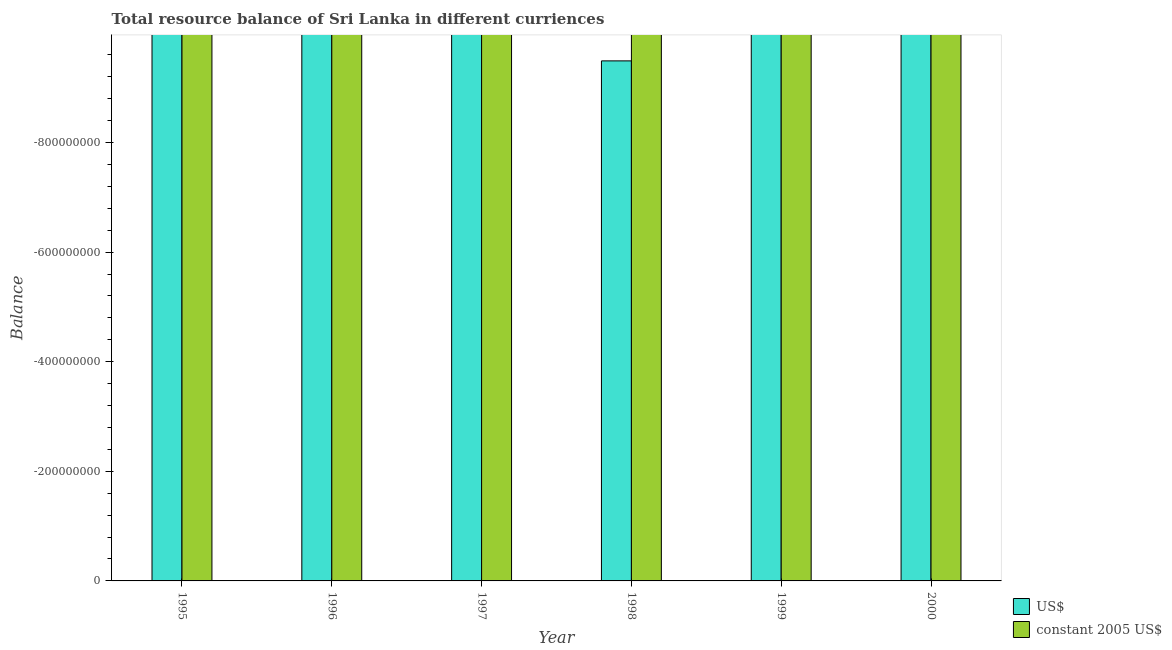Are the number of bars per tick equal to the number of legend labels?
Offer a terse response. No. Are the number of bars on each tick of the X-axis equal?
Your answer should be compact. Yes. How many bars are there on the 5th tick from the left?
Give a very brief answer. 0. What is the resource balance in us$ in 1995?
Provide a short and direct response. 0. Across all years, what is the minimum resource balance in us$?
Your answer should be very brief. 0. What is the total resource balance in us$ in the graph?
Make the answer very short. 0. What is the average resource balance in constant us$ per year?
Provide a short and direct response. 0. In how many years, is the resource balance in constant us$ greater than -920000000 units?
Provide a succinct answer. 0. In how many years, is the resource balance in us$ greater than the average resource balance in us$ taken over all years?
Keep it short and to the point. 0. How many bars are there?
Give a very brief answer. 0. Are the values on the major ticks of Y-axis written in scientific E-notation?
Give a very brief answer. No. Does the graph contain any zero values?
Your response must be concise. Yes. Does the graph contain grids?
Provide a succinct answer. No. How many legend labels are there?
Make the answer very short. 2. What is the title of the graph?
Keep it short and to the point. Total resource balance of Sri Lanka in different curriences. Does "Pregnant women" appear as one of the legend labels in the graph?
Your response must be concise. No. What is the label or title of the Y-axis?
Keep it short and to the point. Balance. What is the Balance of US$ in 1995?
Your answer should be very brief. 0. What is the Balance in US$ in 1996?
Ensure brevity in your answer.  0. What is the Balance of constant 2005 US$ in 1996?
Give a very brief answer. 0. What is the Balance of constant 2005 US$ in 1997?
Give a very brief answer. 0. What is the Balance in constant 2005 US$ in 1998?
Provide a succinct answer. 0. What is the Balance in US$ in 2000?
Provide a short and direct response. 0. What is the Balance in constant 2005 US$ in 2000?
Provide a succinct answer. 0. What is the total Balance in US$ in the graph?
Your answer should be very brief. 0. What is the total Balance of constant 2005 US$ in the graph?
Offer a very short reply. 0. What is the average Balance of US$ per year?
Your answer should be very brief. 0. What is the average Balance of constant 2005 US$ per year?
Provide a short and direct response. 0. 